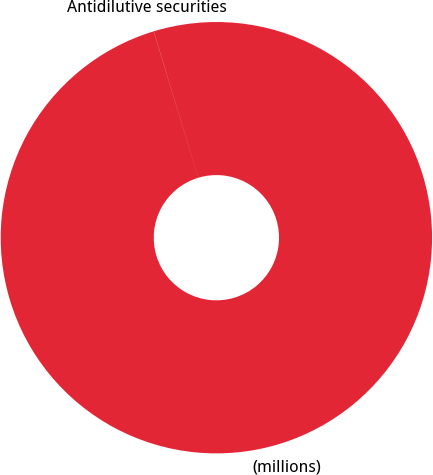Convert chart to OTSL. <chart><loc_0><loc_0><loc_500><loc_500><pie_chart><fcel>(millions)<fcel>Antidilutive securities<nl><fcel>99.99%<fcel>0.01%<nl></chart> 